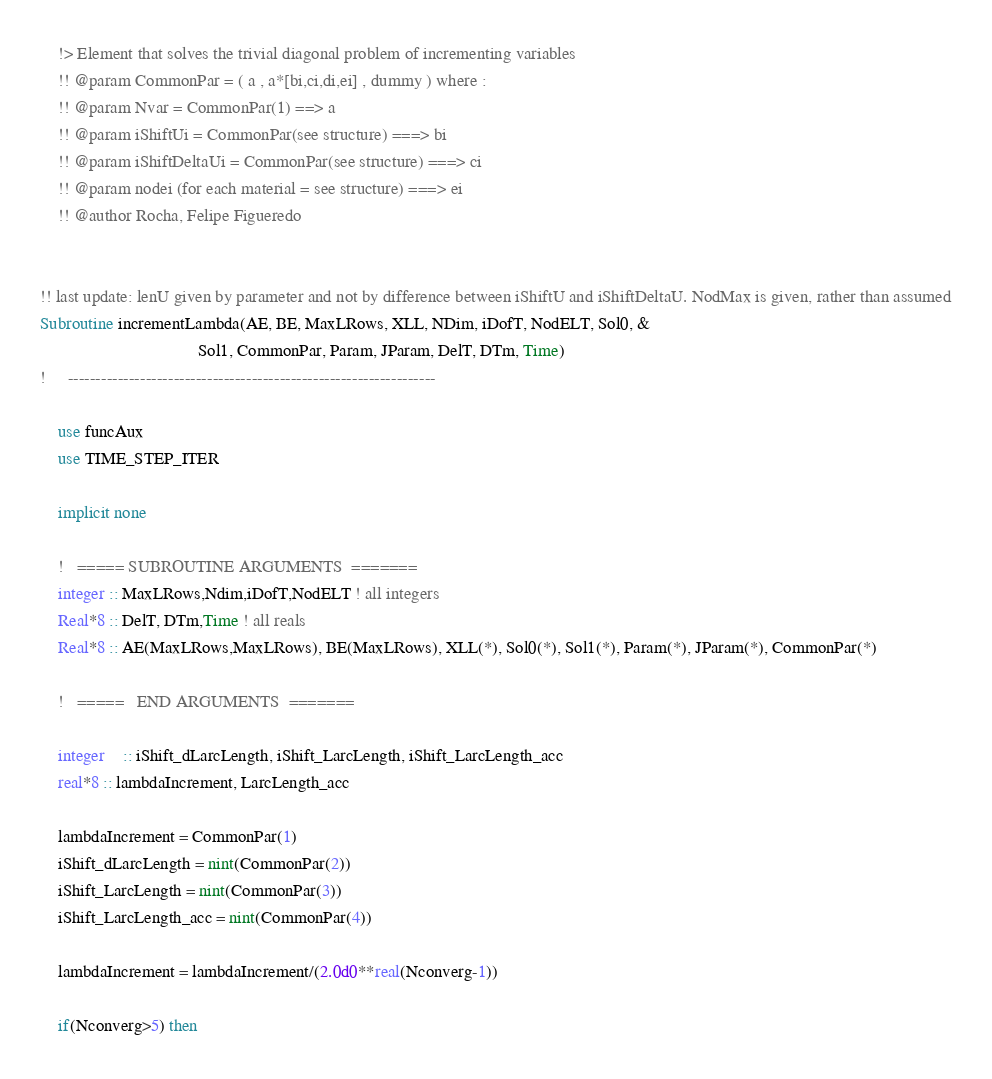Convert code to text. <code><loc_0><loc_0><loc_500><loc_500><_FORTRAN_>	!> Element that solves the trivial diagonal problem of incrementing variables
	!! @param CommonPar = ( a , a*[bi,ci,di,ei] , dummy ) where : 
	!! @param Nvar = CommonPar(1) ==> a
	!! @param iShiftUi = CommonPar(see structure) ===> bi
	!! @param iShiftDeltaUi = CommonPar(see structure) ===> ci
	!! @param nodei (for each material = see structure) ===> ei 
	!! @author Rocha, Felipe Figueredo


!! last update: lenU given by parameter and not by difference between iShiftU and iShiftDeltaU. NodMax is given, rather than assumed
Subroutine incrementLambda(AE, BE, MaxLRows, XLL, NDim, iDofT, NodELT, Sol0, &
									Sol1, CommonPar, Param, JParam, DelT, DTm, Time)
!     ------------------------------------------------------------------

	use funcAux
	use TIME_STEP_ITER
	
	implicit none

	!   ===== SUBROUTINE ARGUMENTS  =======
	integer :: MaxLRows,Ndim,iDofT,NodELT ! all integers
	Real*8 :: DelT, DTm,Time ! all reals
	Real*8 :: AE(MaxLRows,MaxLRows), BE(MaxLRows), XLL(*), Sol0(*), Sol1(*), Param(*), JParam(*), CommonPar(*)

	!   =====   END ARGUMENTS  =======
    
    integer	:: iShift_dLarcLength, iShift_LarcLength, iShift_LarcLength_acc 
    real*8 :: lambdaIncrement, LarcLength_acc
	
	lambdaIncrement = CommonPar(1)
	iShift_dLarcLength = nint(CommonPar(2))
	iShift_LarcLength = nint(CommonPar(3))
	iShift_LarcLength_acc = nint(CommonPar(4))	

	lambdaIncrement = lambdaIncrement/(2.0d0**real(Nconverg-1))
	
	if(Nconverg>5) then</code> 